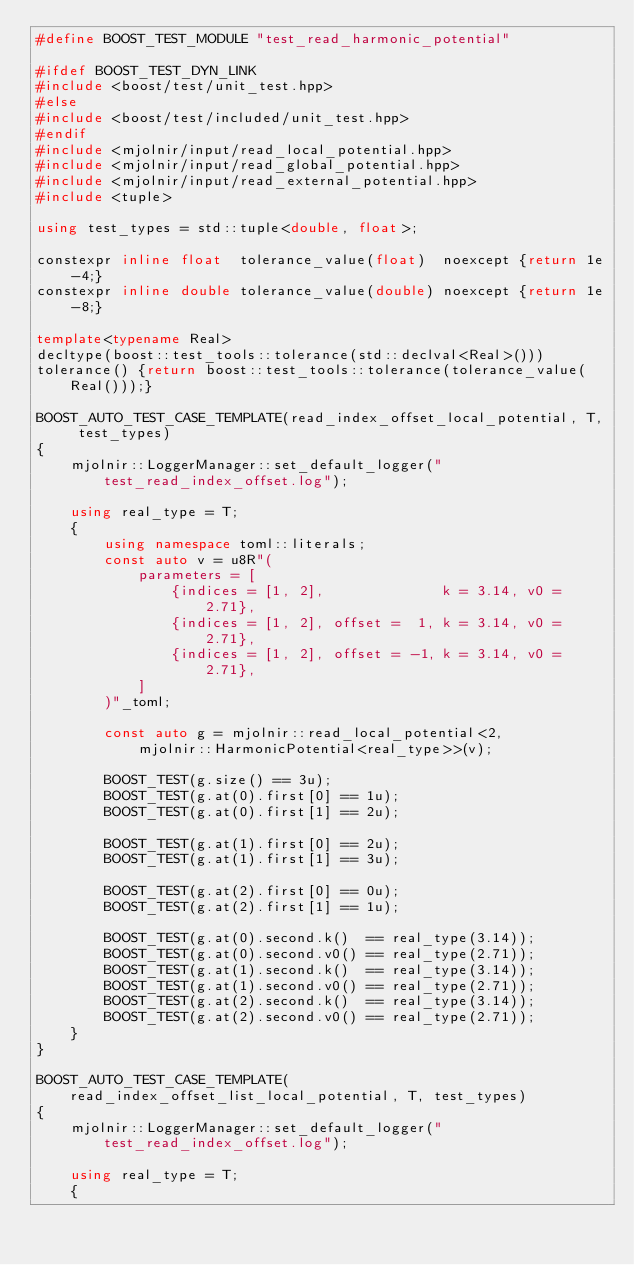Convert code to text. <code><loc_0><loc_0><loc_500><loc_500><_C++_>#define BOOST_TEST_MODULE "test_read_harmonic_potential"

#ifdef BOOST_TEST_DYN_LINK
#include <boost/test/unit_test.hpp>
#else
#include <boost/test/included/unit_test.hpp>
#endif
#include <mjolnir/input/read_local_potential.hpp>
#include <mjolnir/input/read_global_potential.hpp>
#include <mjolnir/input/read_external_potential.hpp>
#include <tuple>

using test_types = std::tuple<double, float>;

constexpr inline float  tolerance_value(float)  noexcept {return 1e-4;}
constexpr inline double tolerance_value(double) noexcept {return 1e-8;}

template<typename Real>
decltype(boost::test_tools::tolerance(std::declval<Real>()))
tolerance() {return boost::test_tools::tolerance(tolerance_value(Real()));}

BOOST_AUTO_TEST_CASE_TEMPLATE(read_index_offset_local_potential, T, test_types)
{
    mjolnir::LoggerManager::set_default_logger("test_read_index_offset.log");

    using real_type = T;
    {
        using namespace toml::literals;
        const auto v = u8R"(
            parameters = [
                {indices = [1, 2],              k = 3.14, v0 = 2.71},
                {indices = [1, 2], offset =  1, k = 3.14, v0 = 2.71},
                {indices = [1, 2], offset = -1, k = 3.14, v0 = 2.71},
            ]
        )"_toml;

        const auto g = mjolnir::read_local_potential<2,
            mjolnir::HarmonicPotential<real_type>>(v);

        BOOST_TEST(g.size() == 3u);
        BOOST_TEST(g.at(0).first[0] == 1u);
        BOOST_TEST(g.at(0).first[1] == 2u);

        BOOST_TEST(g.at(1).first[0] == 2u);
        BOOST_TEST(g.at(1).first[1] == 3u);

        BOOST_TEST(g.at(2).first[0] == 0u);
        BOOST_TEST(g.at(2).first[1] == 1u);

        BOOST_TEST(g.at(0).second.k()  == real_type(3.14));
        BOOST_TEST(g.at(0).second.v0() == real_type(2.71));
        BOOST_TEST(g.at(1).second.k()  == real_type(3.14));
        BOOST_TEST(g.at(1).second.v0() == real_type(2.71));
        BOOST_TEST(g.at(2).second.k()  == real_type(3.14));
        BOOST_TEST(g.at(2).second.v0() == real_type(2.71));
    }
}

BOOST_AUTO_TEST_CASE_TEMPLATE(read_index_offset_list_local_potential, T, test_types)
{
    mjolnir::LoggerManager::set_default_logger("test_read_index_offset.log");

    using real_type = T;
    {</code> 